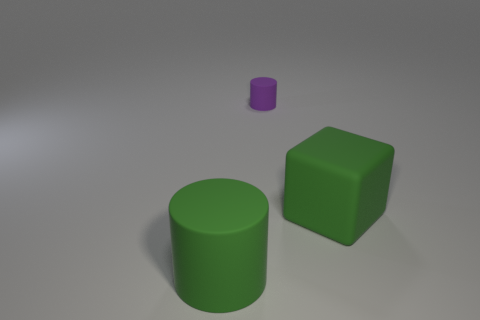Add 3 tiny rubber cylinders. How many objects exist? 6 Subtract all cylinders. How many objects are left? 1 Add 1 large green matte cubes. How many large green matte cubes exist? 2 Subtract 0 yellow balls. How many objects are left? 3 Subtract all large yellow objects. Subtract all green cylinders. How many objects are left? 2 Add 1 large rubber objects. How many large rubber objects are left? 3 